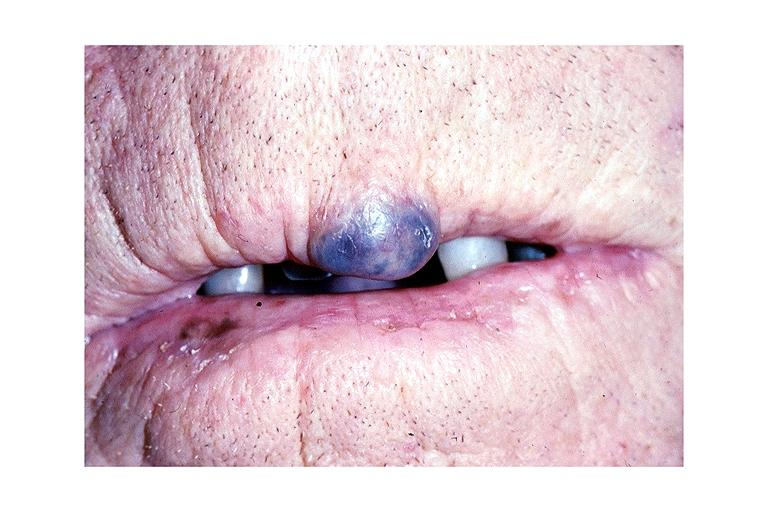what is present?
Answer the question using a single word or phrase. Oral 